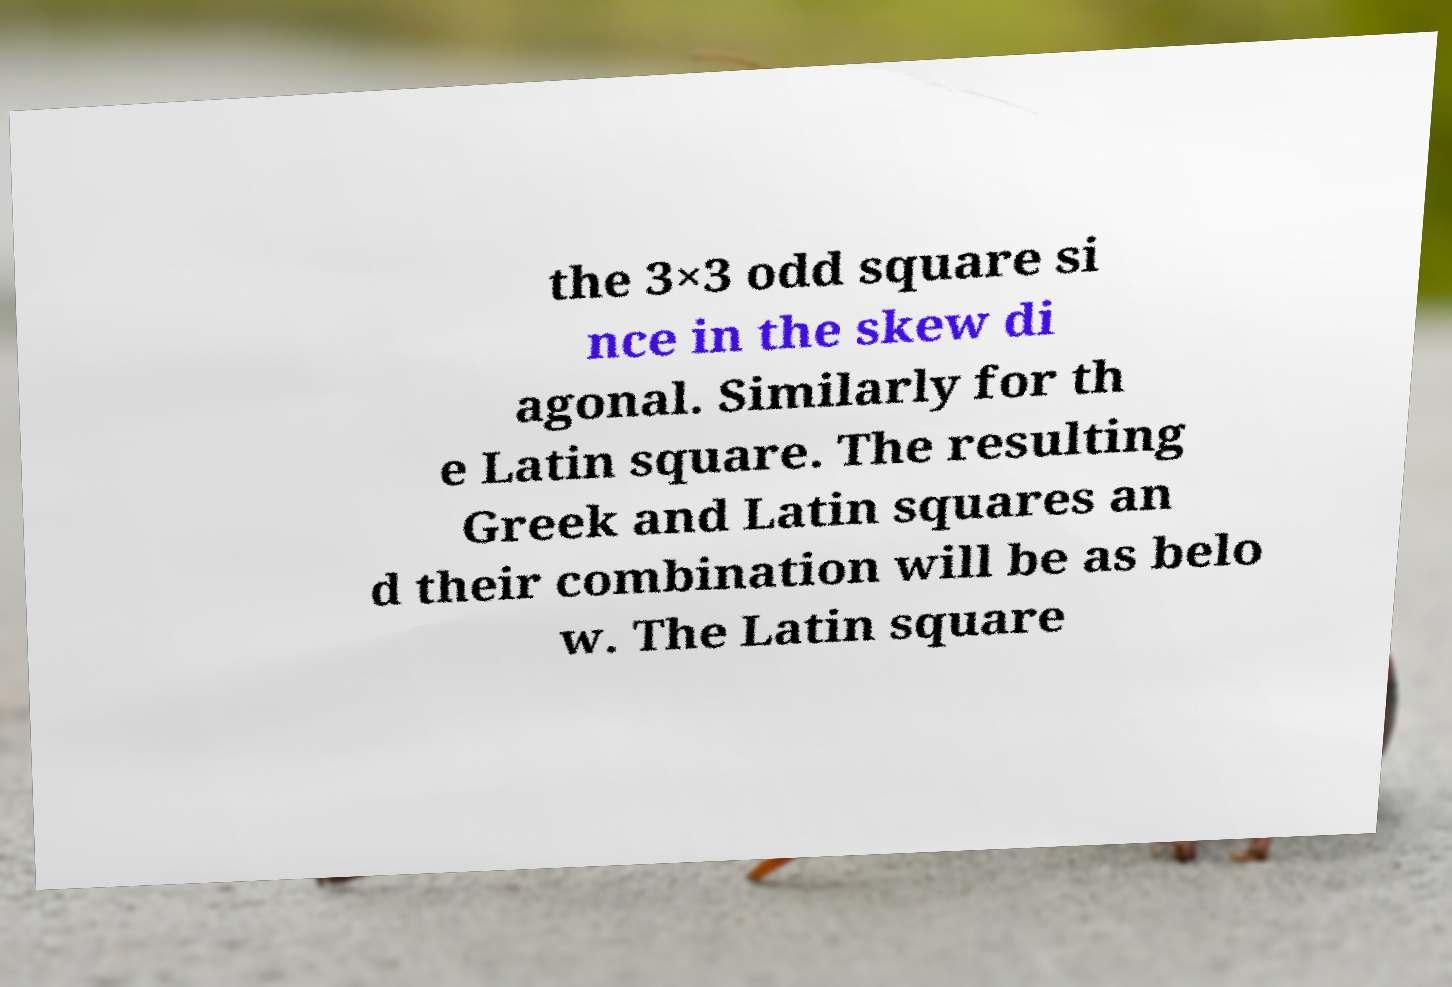For documentation purposes, I need the text within this image transcribed. Could you provide that? the 3×3 odd square si nce in the skew di agonal. Similarly for th e Latin square. The resulting Greek and Latin squares an d their combination will be as belo w. The Latin square 